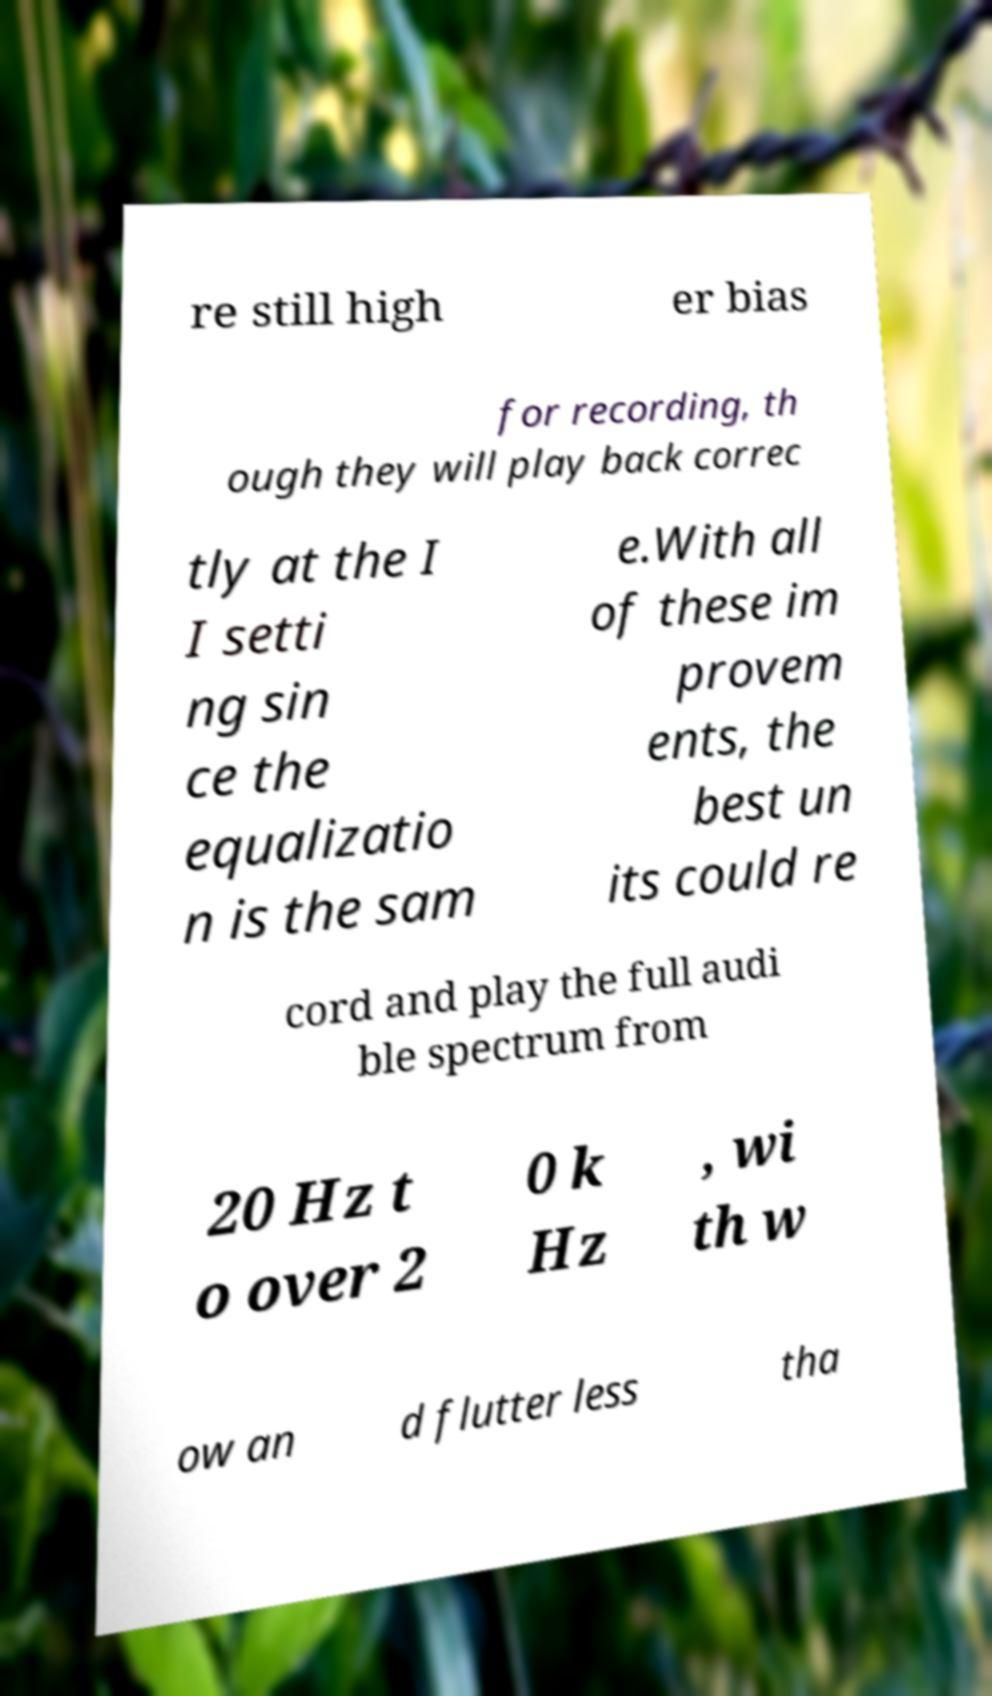Could you extract and type out the text from this image? re still high er bias for recording, th ough they will play back correc tly at the I I setti ng sin ce the equalizatio n is the sam e.With all of these im provem ents, the best un its could re cord and play the full audi ble spectrum from 20 Hz t o over 2 0 k Hz , wi th w ow an d flutter less tha 